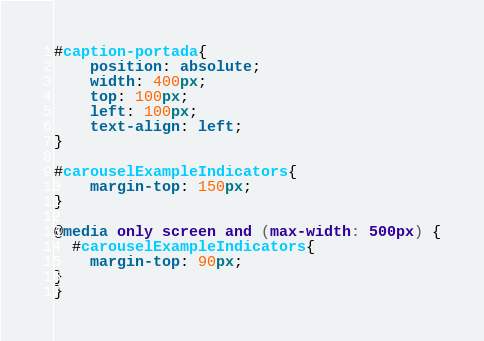Convert code to text. <code><loc_0><loc_0><loc_500><loc_500><_CSS_>#caption-portada{
	position: absolute;
	width: 400px;
	top: 100px;
	left: 100px;
	text-align: left;
}

#carouselExampleIndicators{
	margin-top: 150px;
}

@media only screen and (max-width: 500px) {
  #carouselExampleIndicators{
	margin-top: 90px;
}
}</code> 